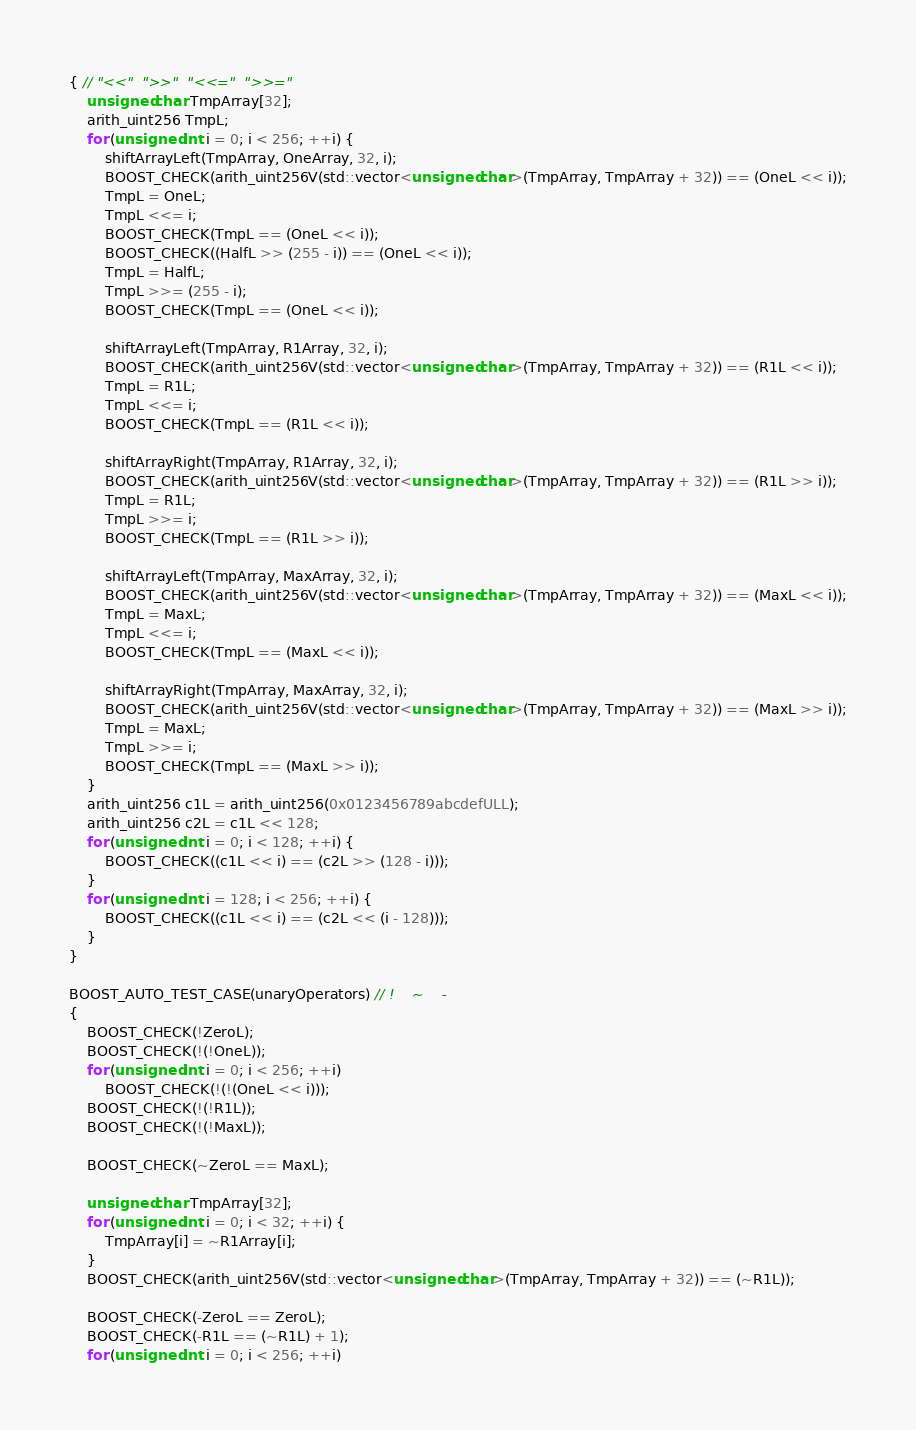Convert code to text. <code><loc_0><loc_0><loc_500><loc_500><_C++_>{ // "<<"  ">>"  "<<="  ">>="
    unsigned char TmpArray[32];
    arith_uint256 TmpL;
    for (unsigned int i = 0; i < 256; ++i) {
        shiftArrayLeft(TmpArray, OneArray, 32, i);
        BOOST_CHECK(arith_uint256V(std::vector<unsigned char>(TmpArray, TmpArray + 32)) == (OneL << i));
        TmpL = OneL;
        TmpL <<= i;
        BOOST_CHECK(TmpL == (OneL << i));
        BOOST_CHECK((HalfL >> (255 - i)) == (OneL << i));
        TmpL = HalfL;
        TmpL >>= (255 - i);
        BOOST_CHECK(TmpL == (OneL << i));

        shiftArrayLeft(TmpArray, R1Array, 32, i);
        BOOST_CHECK(arith_uint256V(std::vector<unsigned char>(TmpArray, TmpArray + 32)) == (R1L << i));
        TmpL = R1L;
        TmpL <<= i;
        BOOST_CHECK(TmpL == (R1L << i));

        shiftArrayRight(TmpArray, R1Array, 32, i);
        BOOST_CHECK(arith_uint256V(std::vector<unsigned char>(TmpArray, TmpArray + 32)) == (R1L >> i));
        TmpL = R1L;
        TmpL >>= i;
        BOOST_CHECK(TmpL == (R1L >> i));

        shiftArrayLeft(TmpArray, MaxArray, 32, i);
        BOOST_CHECK(arith_uint256V(std::vector<unsigned char>(TmpArray, TmpArray + 32)) == (MaxL << i));
        TmpL = MaxL;
        TmpL <<= i;
        BOOST_CHECK(TmpL == (MaxL << i));

        shiftArrayRight(TmpArray, MaxArray, 32, i);
        BOOST_CHECK(arith_uint256V(std::vector<unsigned char>(TmpArray, TmpArray + 32)) == (MaxL >> i));
        TmpL = MaxL;
        TmpL >>= i;
        BOOST_CHECK(TmpL == (MaxL >> i));
    }
    arith_uint256 c1L = arith_uint256(0x0123456789abcdefULL);
    arith_uint256 c2L = c1L << 128;
    for (unsigned int i = 0; i < 128; ++i) {
        BOOST_CHECK((c1L << i) == (c2L >> (128 - i)));
    }
    for (unsigned int i = 128; i < 256; ++i) {
        BOOST_CHECK((c1L << i) == (c2L << (i - 128)));
    }
}

BOOST_AUTO_TEST_CASE(unaryOperators) // !    ~    -
{
    BOOST_CHECK(!ZeroL);
    BOOST_CHECK(!(!OneL));
    for (unsigned int i = 0; i < 256; ++i)
        BOOST_CHECK(!(!(OneL << i)));
    BOOST_CHECK(!(!R1L));
    BOOST_CHECK(!(!MaxL));

    BOOST_CHECK(~ZeroL == MaxL);

    unsigned char TmpArray[32];
    for (unsigned int i = 0; i < 32; ++i) {
        TmpArray[i] = ~R1Array[i];
    }
    BOOST_CHECK(arith_uint256V(std::vector<unsigned char>(TmpArray, TmpArray + 32)) == (~R1L));

    BOOST_CHECK(-ZeroL == ZeroL);
    BOOST_CHECK(-R1L == (~R1L) + 1);
    for (unsigned int i = 0; i < 256; ++i)</code> 